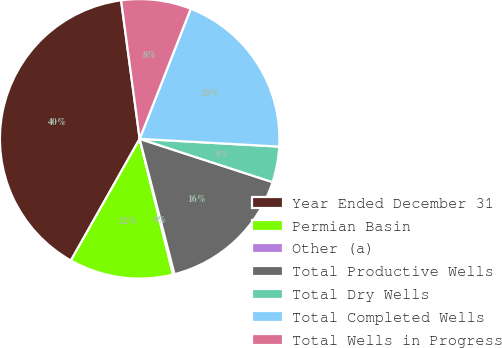Convert chart. <chart><loc_0><loc_0><loc_500><loc_500><pie_chart><fcel>Year Ended December 31<fcel>Permian Basin<fcel>Other (a)<fcel>Total Productive Wells<fcel>Total Dry Wells<fcel>Total Completed Wells<fcel>Total Wells in Progress<nl><fcel>39.69%<fcel>12.03%<fcel>0.17%<fcel>15.98%<fcel>4.13%<fcel>19.93%<fcel>8.08%<nl></chart> 